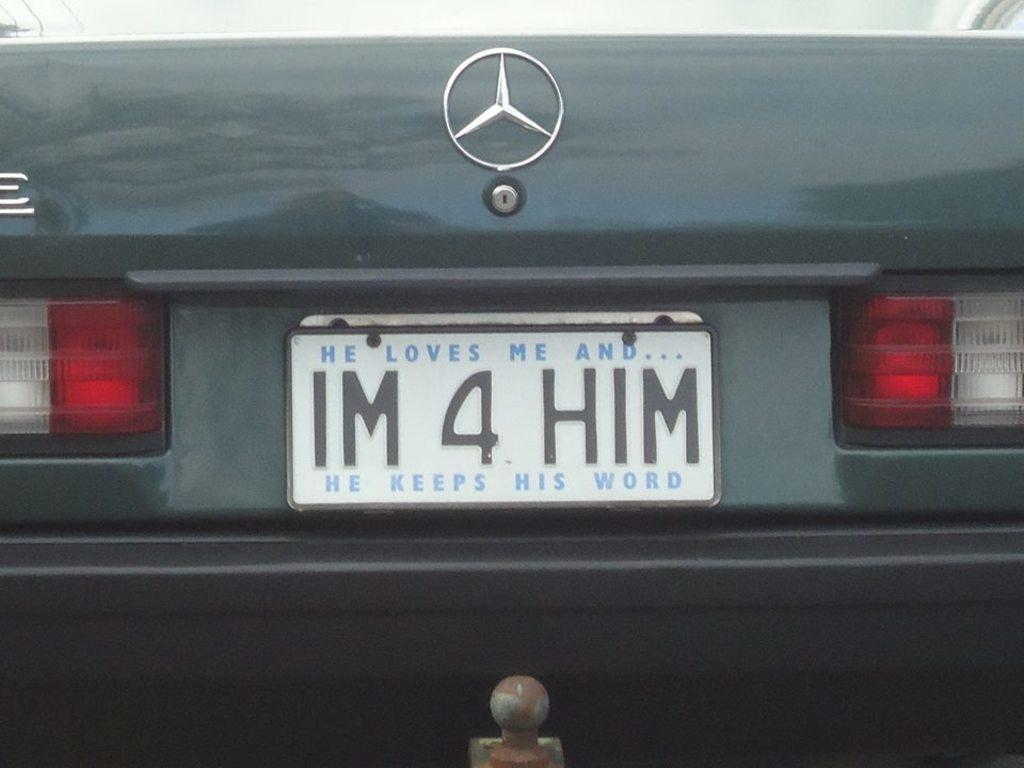What does he keep?
Offer a very short reply. His word. What is the license plate number of this car?
Offer a very short reply. Im 4 him. 